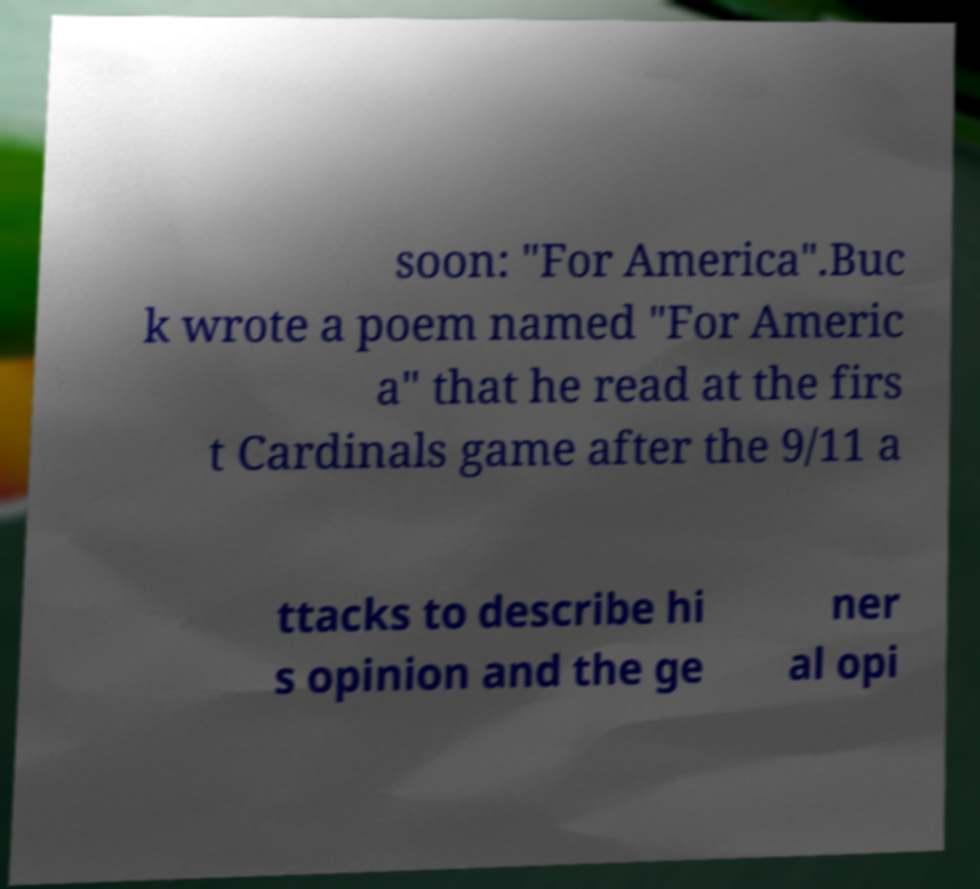I need the written content from this picture converted into text. Can you do that? soon: "For America".Buc k wrote a poem named "For Americ a" that he read at the firs t Cardinals game after the 9/11 a ttacks to describe hi s opinion and the ge ner al opi 